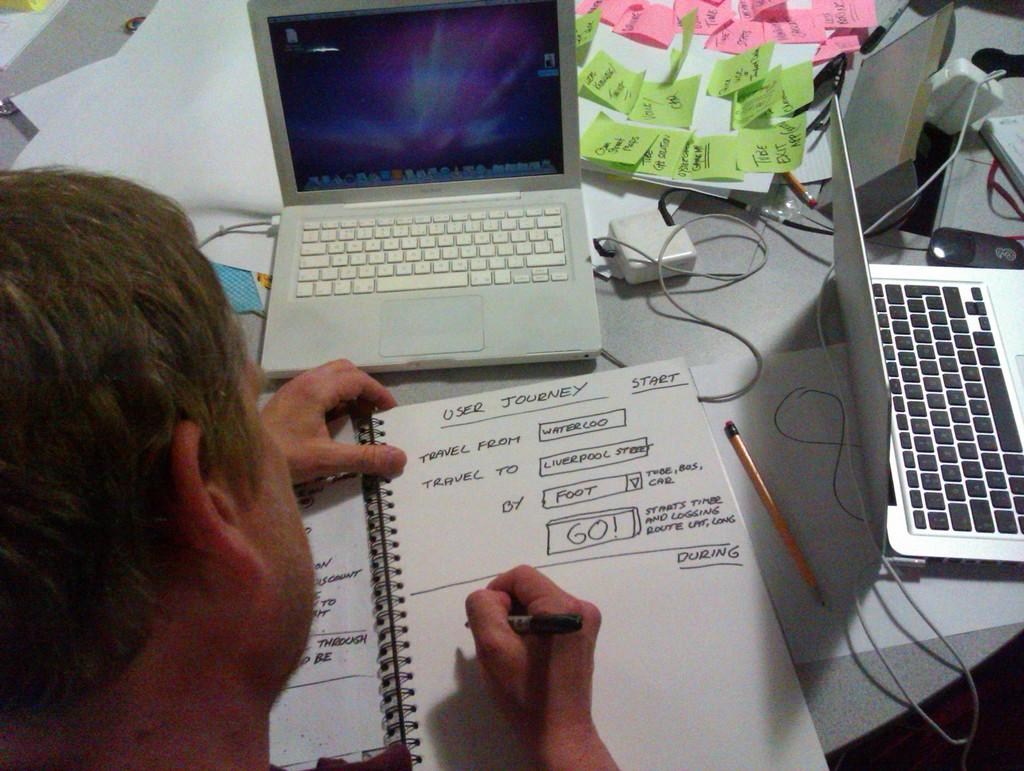<image>
Summarize the visual content of the image. A man writing in a book titled user journey 